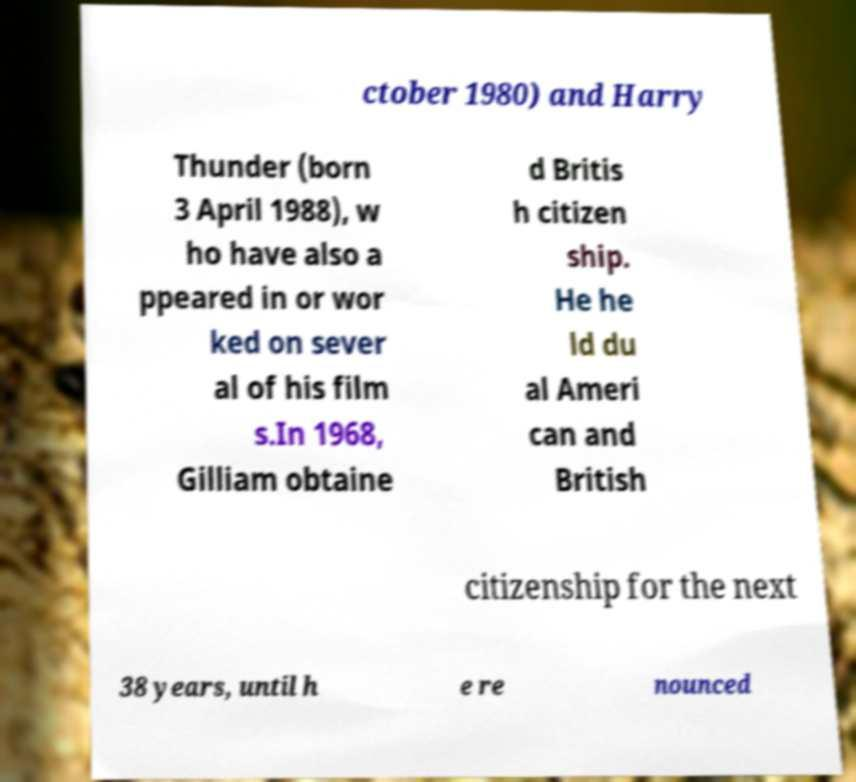Can you read and provide the text displayed in the image?This photo seems to have some interesting text. Can you extract and type it out for me? ctober 1980) and Harry Thunder (born 3 April 1988), w ho have also a ppeared in or wor ked on sever al of his film s.In 1968, Gilliam obtaine d Britis h citizen ship. He he ld du al Ameri can and British citizenship for the next 38 years, until h e re nounced 